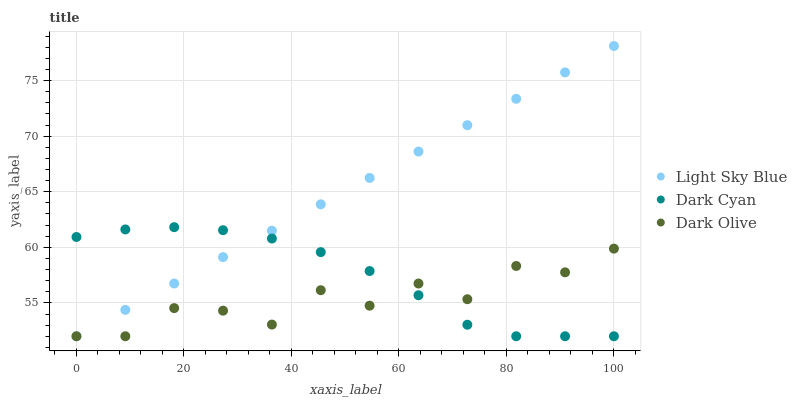Does Dark Olive have the minimum area under the curve?
Answer yes or no. Yes. Does Light Sky Blue have the maximum area under the curve?
Answer yes or no. Yes. Does Light Sky Blue have the minimum area under the curve?
Answer yes or no. No. Does Dark Olive have the maximum area under the curve?
Answer yes or no. No. Is Light Sky Blue the smoothest?
Answer yes or no. Yes. Is Dark Olive the roughest?
Answer yes or no. Yes. Is Dark Olive the smoothest?
Answer yes or no. No. Is Light Sky Blue the roughest?
Answer yes or no. No. Does Dark Cyan have the lowest value?
Answer yes or no. Yes. Does Light Sky Blue have the highest value?
Answer yes or no. Yes. Does Dark Olive have the highest value?
Answer yes or no. No. Does Dark Olive intersect Dark Cyan?
Answer yes or no. Yes. Is Dark Olive less than Dark Cyan?
Answer yes or no. No. Is Dark Olive greater than Dark Cyan?
Answer yes or no. No. 